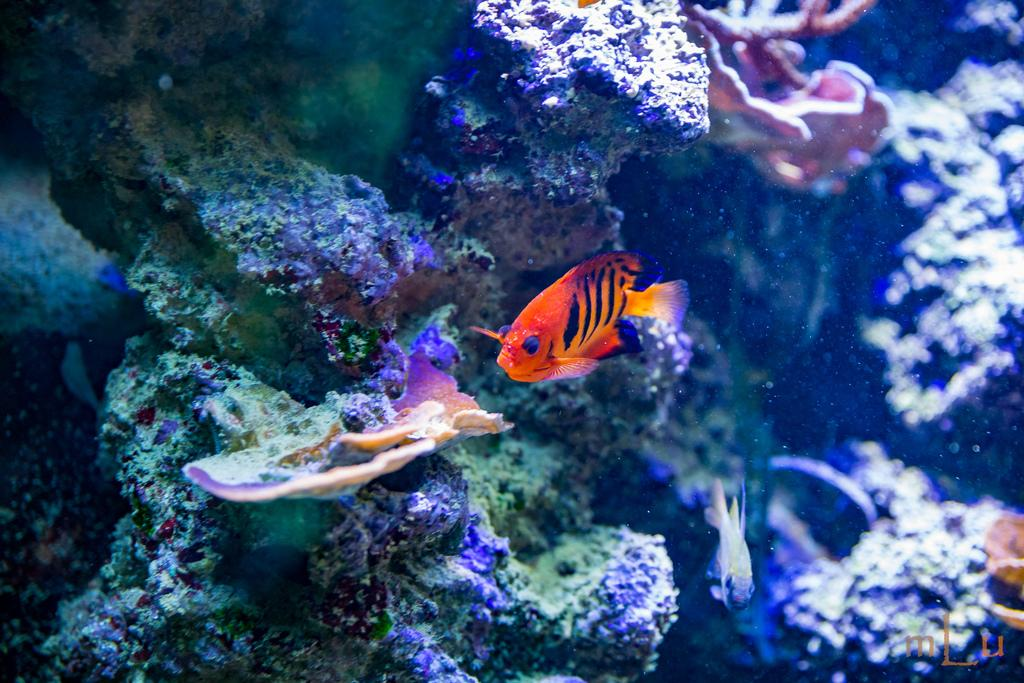What is the main subject in the center of the image? There is a fish in the center of the image. What can be seen in the background of the image? There are water plants in the background of the image. What is the primary element visible in the image? There is water visible in the image. How many squirrels are in the image? There are no squirrels present in the image. On which side of the image is the flock of birds located? There is no flock of birds present in the image. 